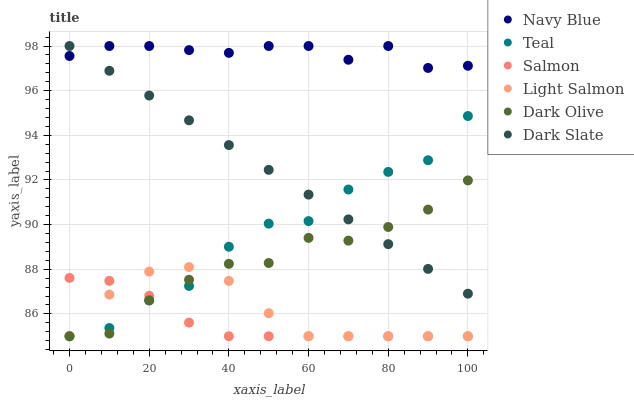Does Salmon have the minimum area under the curve?
Answer yes or no. Yes. Does Navy Blue have the maximum area under the curve?
Answer yes or no. Yes. Does Dark Olive have the minimum area under the curve?
Answer yes or no. No. Does Dark Olive have the maximum area under the curve?
Answer yes or no. No. Is Dark Slate the smoothest?
Answer yes or no. Yes. Is Teal the roughest?
Answer yes or no. Yes. Is Navy Blue the smoothest?
Answer yes or no. No. Is Navy Blue the roughest?
Answer yes or no. No. Does Light Salmon have the lowest value?
Answer yes or no. Yes. Does Navy Blue have the lowest value?
Answer yes or no. No. Does Dark Slate have the highest value?
Answer yes or no. Yes. Does Dark Olive have the highest value?
Answer yes or no. No. Is Dark Olive less than Navy Blue?
Answer yes or no. Yes. Is Navy Blue greater than Light Salmon?
Answer yes or no. Yes. Does Salmon intersect Teal?
Answer yes or no. Yes. Is Salmon less than Teal?
Answer yes or no. No. Is Salmon greater than Teal?
Answer yes or no. No. Does Dark Olive intersect Navy Blue?
Answer yes or no. No. 